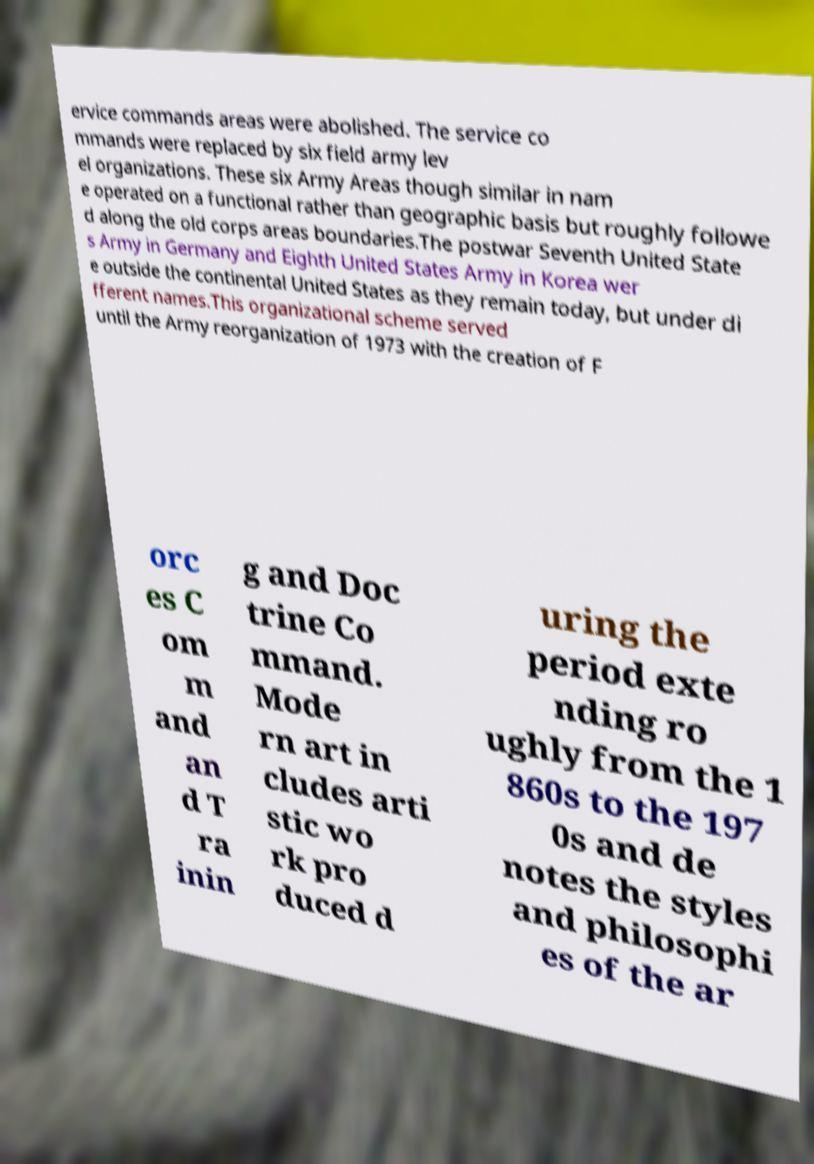There's text embedded in this image that I need extracted. Can you transcribe it verbatim? ervice commands areas were abolished. The service co mmands were replaced by six field army lev el organizations. These six Army Areas though similar in nam e operated on a functional rather than geographic basis but roughly followe d along the old corps areas boundaries.The postwar Seventh United State s Army in Germany and Eighth United States Army in Korea wer e outside the continental United States as they remain today, but under di fferent names.This organizational scheme served until the Army reorganization of 1973 with the creation of F orc es C om m and an d T ra inin g and Doc trine Co mmand. Mode rn art in cludes arti stic wo rk pro duced d uring the period exte nding ro ughly from the 1 860s to the 197 0s and de notes the styles and philosophi es of the ar 